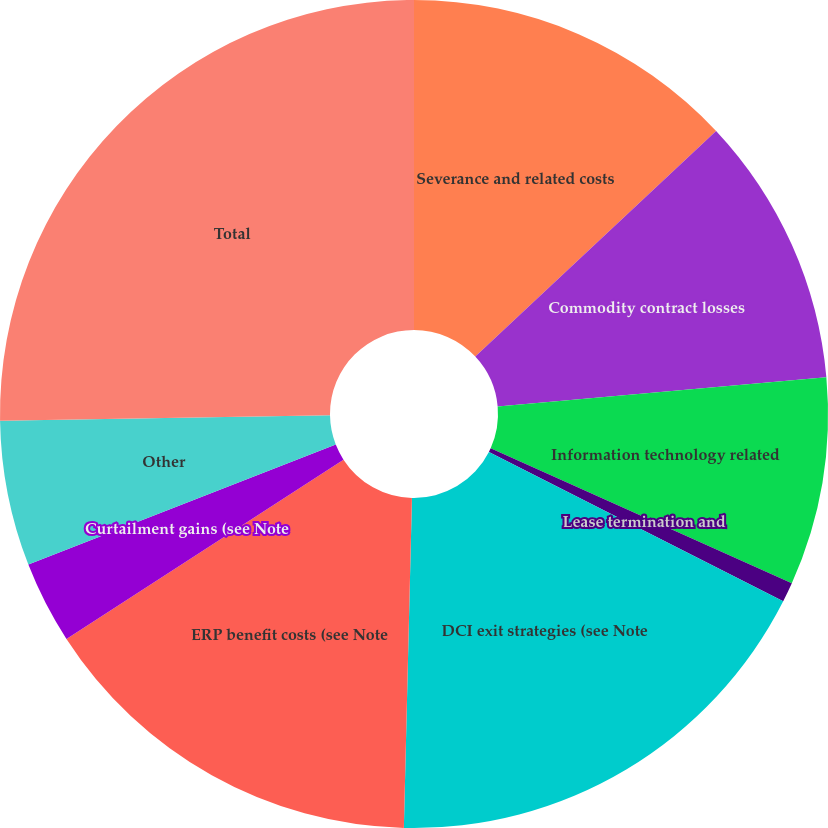Convert chart to OTSL. <chart><loc_0><loc_0><loc_500><loc_500><pie_chart><fcel>Severance and related costs<fcel>Commodity contract losses<fcel>Information technology related<fcel>Lease termination and<fcel>DCI exit strategies (see Note<fcel>ERP benefit costs (see Note<fcel>Curtailment gains (see Note<fcel>Other<fcel>Total<nl><fcel>13.02%<fcel>10.57%<fcel>8.12%<fcel>0.77%<fcel>17.92%<fcel>15.47%<fcel>3.22%<fcel>5.67%<fcel>25.26%<nl></chart> 